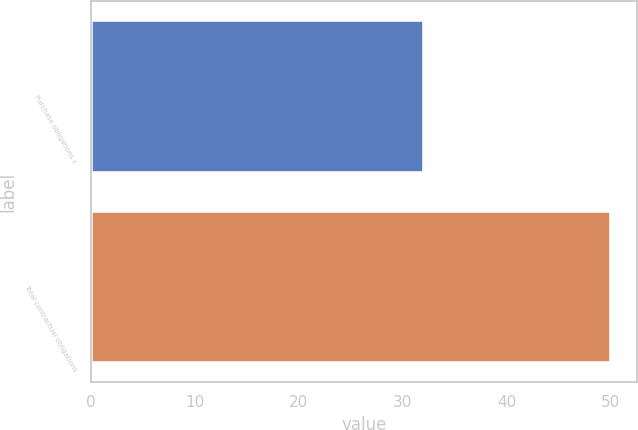Convert chart to OTSL. <chart><loc_0><loc_0><loc_500><loc_500><bar_chart><fcel>Purchase obligations c<fcel>Total contractual obligations<nl><fcel>32<fcel>50<nl></chart> 